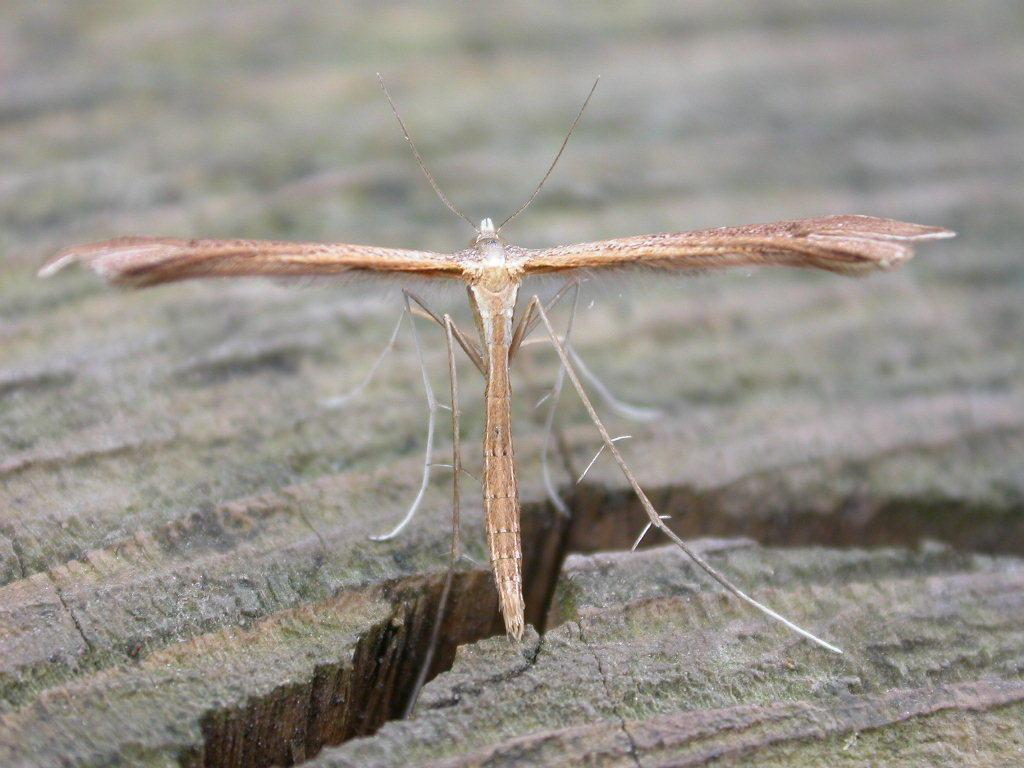What type of creature is present in the image? There is an insect in the image. Where is the insect located? The insect is on a surface. What type of paste is being used by the insect in the image? There is no paste present in the image, and the insect is not using any paste. 